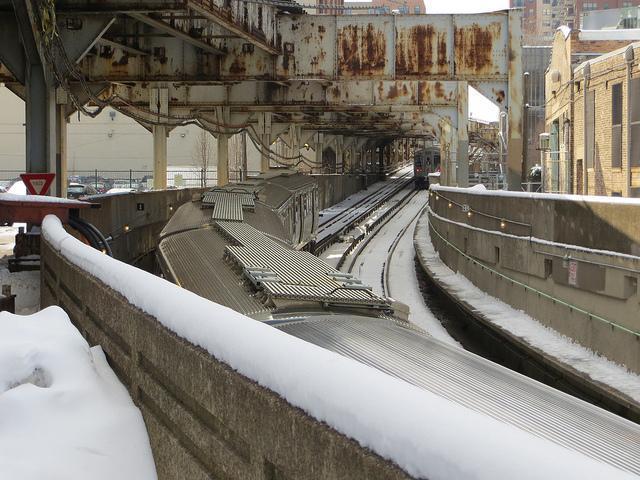How many trains are there?
Give a very brief answer. 1. 